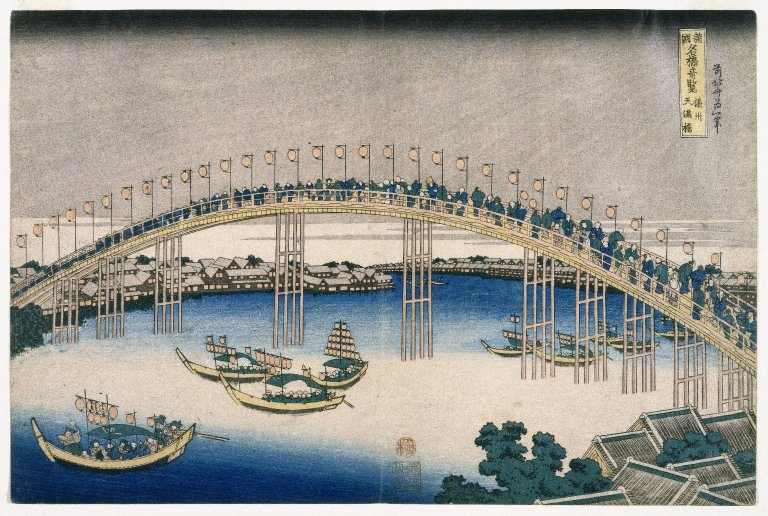Can you tell more about the style of art used in this image? This image is crafted in the ukiyo-e art style, a genre developed in Japan during the 17th through 19th centuries. Ukiyo-e, or 'pictures of the floating world,' captures the fleeting beauty and dynamic urban culture of Japan's Edo period. This style is particularly known for its vibrant use of colors and refined depictions of landscapes, cityscapes, and scenes of daily life, often integrating a strong narrative element. 